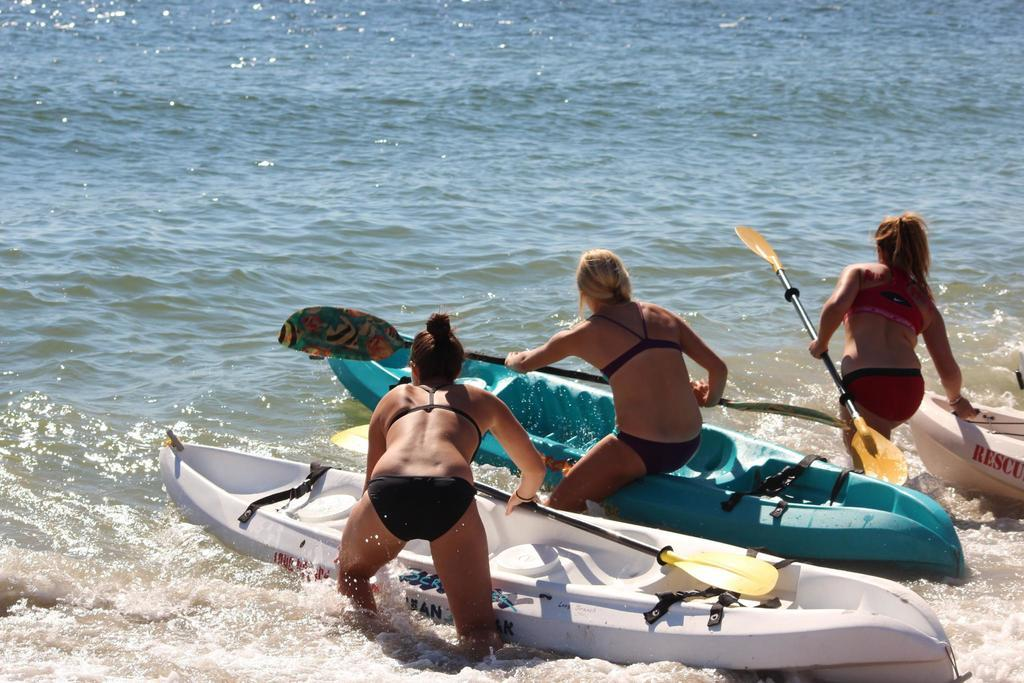What type of vehicles are in the water in the image? There are boats in the water in the image. What other subjects can be seen in the image? There are women in the image. What is the purpose of the skate in the image? There is no skate present in the image. Are the women in the image participating in a protest? There is no indication in the image that the women are participating in a protest. 